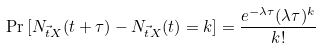Convert formula to latex. <formula><loc_0><loc_0><loc_500><loc_500>\Pr \left [ N _ { \vec { t } { X } } ( t + \tau ) - N _ { \vec { t } { X } } ( t ) = k \right ] = \frac { e ^ { - \lambda \tau } ( \lambda \tau ) ^ { k } } { k ! }</formula> 